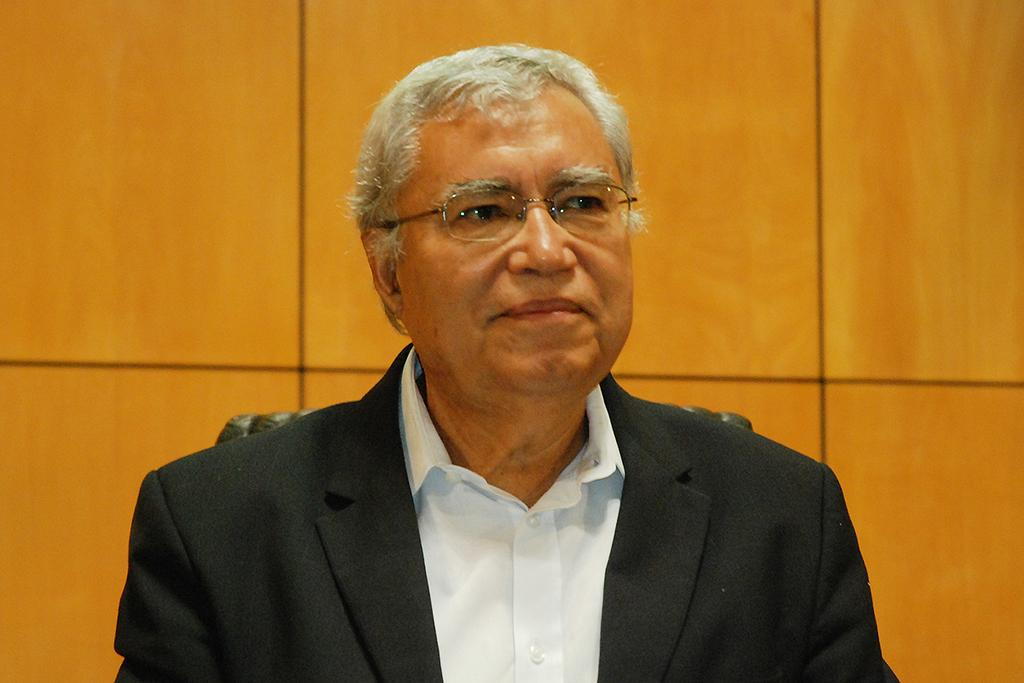Who is present in the image? There is a man in the image. What is the man wearing on his upper body? The man is wearing a black coat and a white shirt. What is the man doing in the image? The man is sitting on a chair and smiling. What can be seen in the background of the image? There is a wooden panel wall in the background of the image. What type of blade is the man holding in the image? There is no blade present in the image; the man is simply sitting and smiling. 